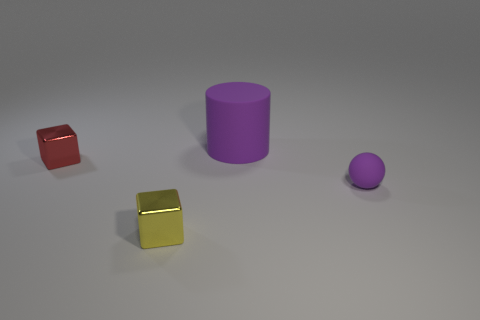Is the rubber cylinder the same color as the tiny rubber sphere?
Provide a succinct answer. Yes. There is a matte thing that is the same color as the sphere; what size is it?
Provide a succinct answer. Large. Are there any other things that have the same color as the big cylinder?
Your answer should be compact. Yes. There is a matte thing that is behind the small purple matte ball; is it the same color as the rubber object that is in front of the large rubber thing?
Ensure brevity in your answer.  Yes. There is a object that is right of the purple cylinder; how many small red metal cubes are behind it?
Your response must be concise. 1. There is a tiny yellow object that is the same material as the tiny red block; what shape is it?
Make the answer very short. Cube. What number of purple objects are either matte objects or rubber cubes?
Give a very brief answer. 2. Is there a shiny block that is behind the tiny block in front of the tiny cube behind the yellow metal thing?
Give a very brief answer. Yes. Is the number of tiny brown shiny blocks less than the number of purple rubber spheres?
Offer a terse response. Yes. Does the small object behind the tiny purple matte sphere have the same shape as the large purple thing?
Your answer should be very brief. No. 